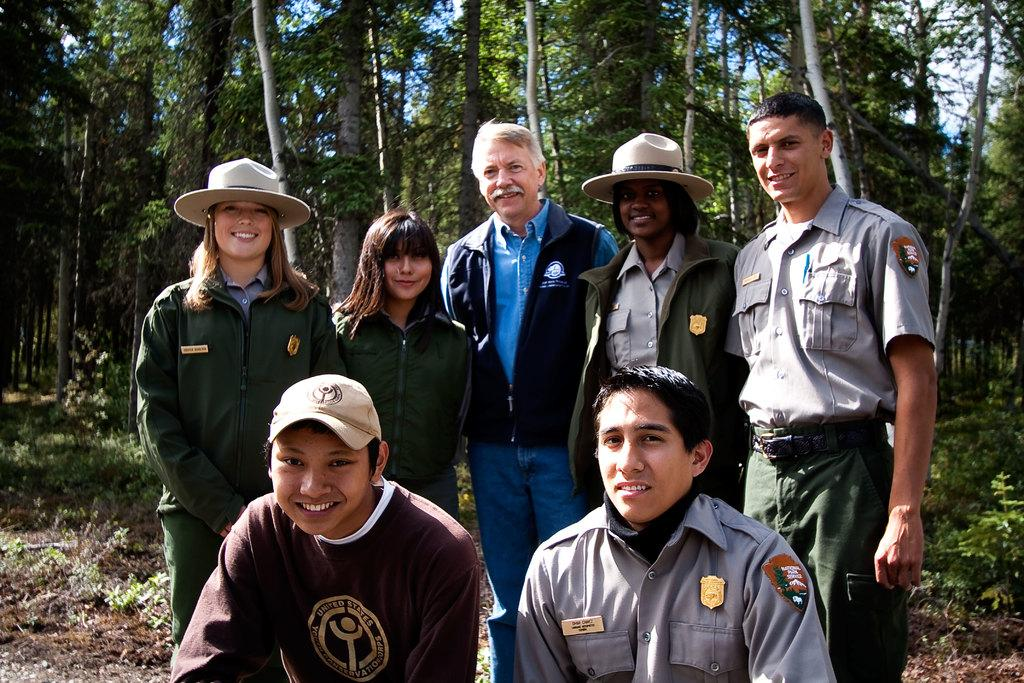What is happening in the image? There are people standing in the image. Can you describe the clothing of some of the people? Some of the people are wearing caps. What type of natural environment is visible in the image? There are trees visible in the image. What type of vegetation is present on the ground? There are plants on the ground in the image. What type of tin is being used to create the country in the image? There is no tin or country present in the image; it features people standing with trees and plants in the background. What type of silk is draped over the plants in the image? There is no silk present in the image; it only shows plants on the ground. 